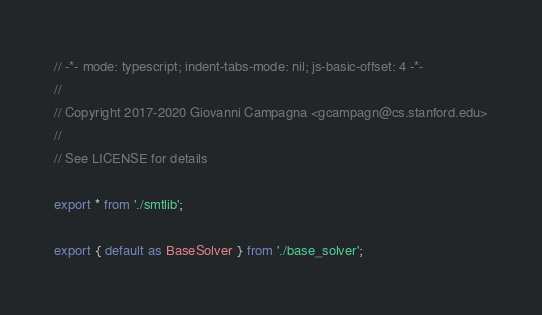<code> <loc_0><loc_0><loc_500><loc_500><_TypeScript_>// -*- mode: typescript; indent-tabs-mode: nil; js-basic-offset: 4 -*-
//
// Copyright 2017-2020 Giovanni Campagna <gcampagn@cs.stanford.edu>
//
// See LICENSE for details

export * from './smtlib';

export { default as BaseSolver } from './base_solver';
</code> 